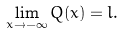<formula> <loc_0><loc_0><loc_500><loc_500>\lim _ { x \rightarrow - \infty } Q ( x ) = l .</formula> 